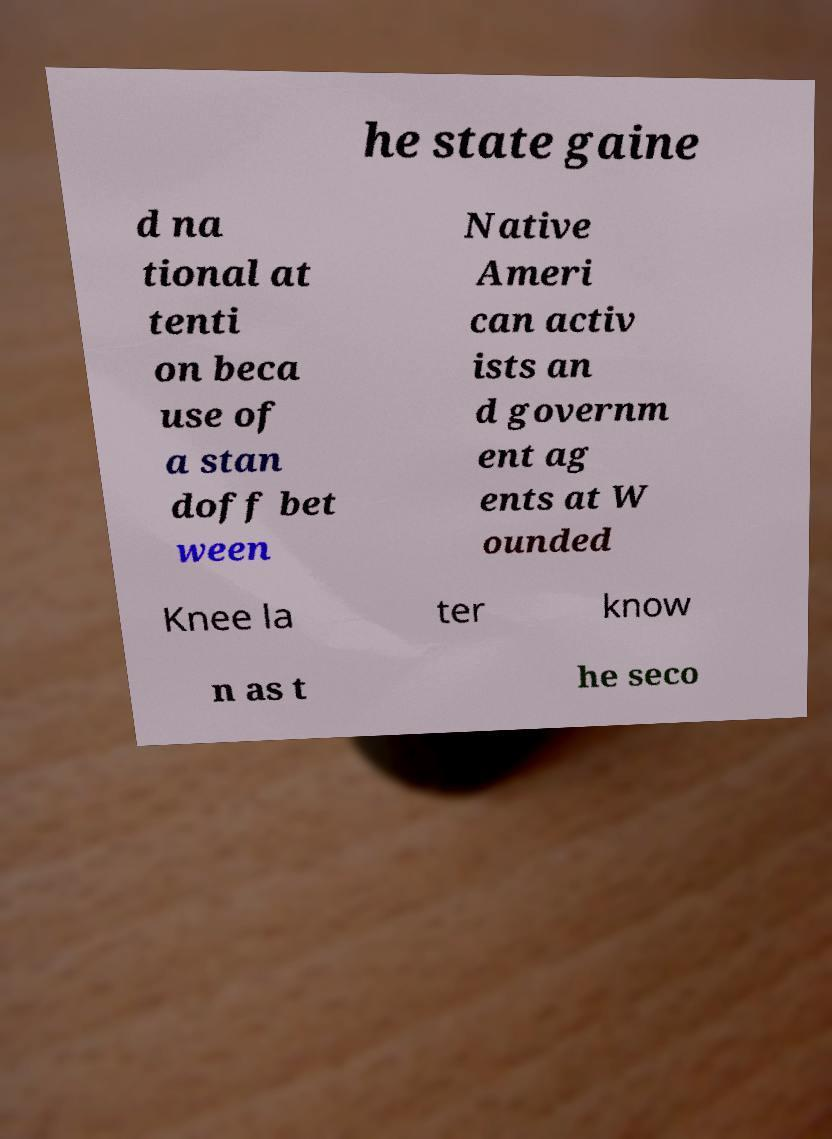Can you accurately transcribe the text from the provided image for me? he state gaine d na tional at tenti on beca use of a stan doff bet ween Native Ameri can activ ists an d governm ent ag ents at W ounded Knee la ter know n as t he seco 